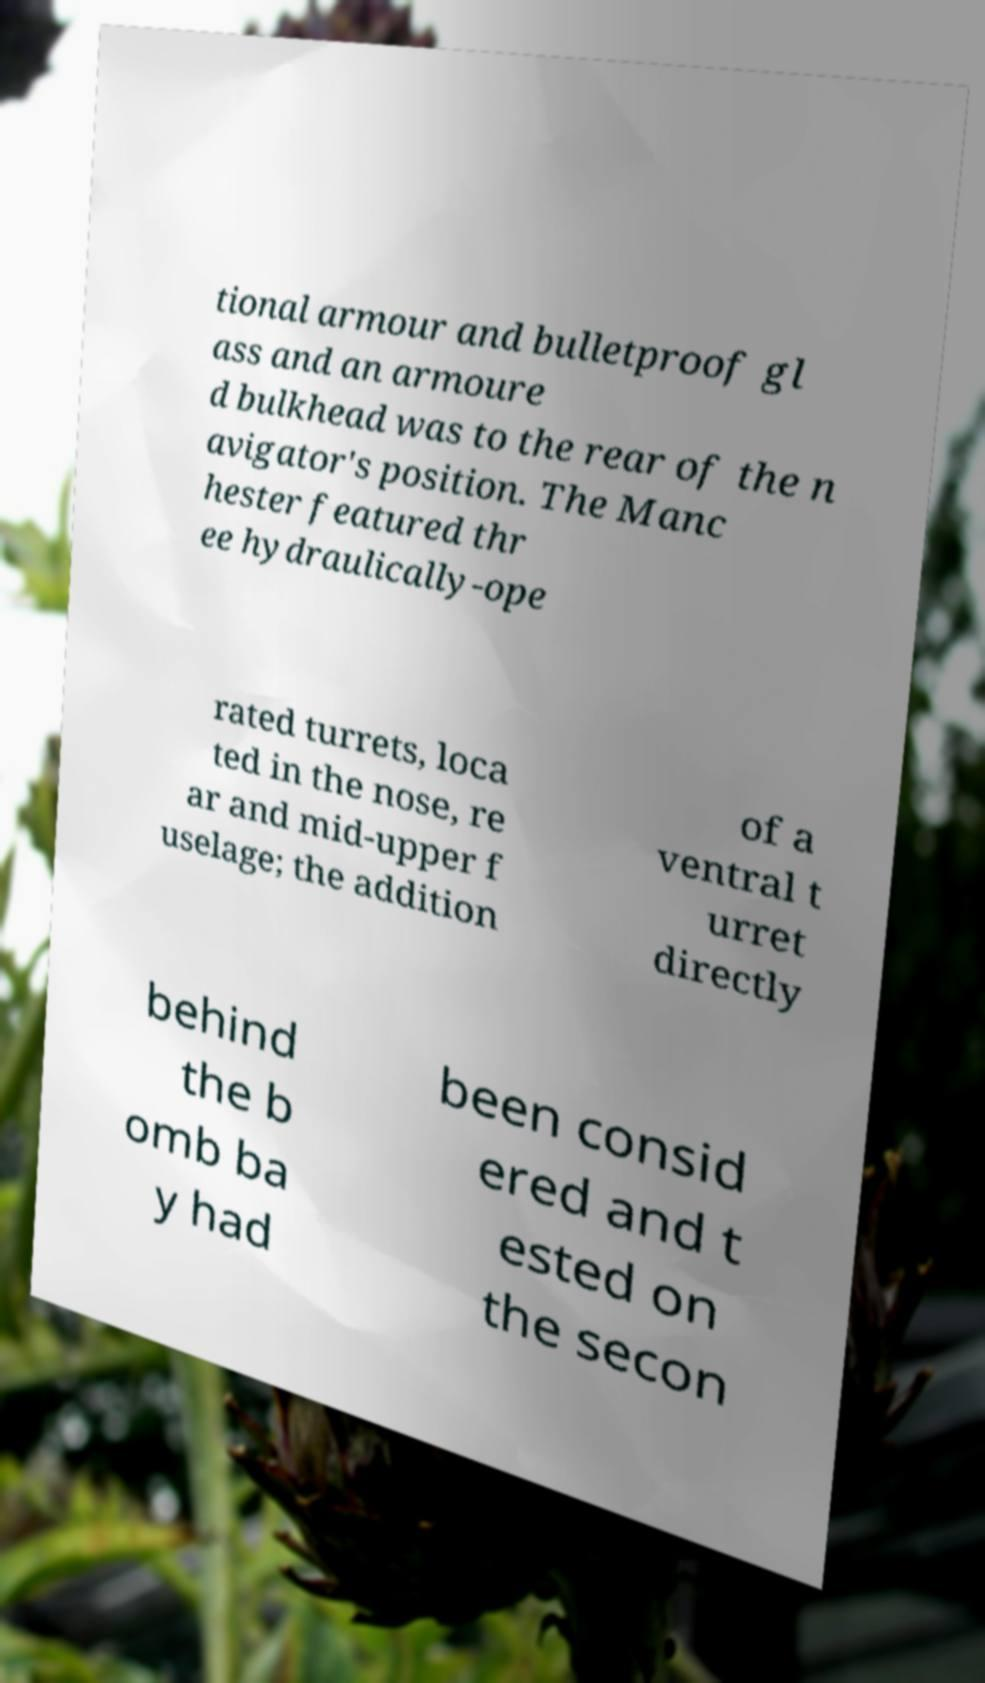For documentation purposes, I need the text within this image transcribed. Could you provide that? tional armour and bulletproof gl ass and an armoure d bulkhead was to the rear of the n avigator's position. The Manc hester featured thr ee hydraulically-ope rated turrets, loca ted in the nose, re ar and mid-upper f uselage; the addition of a ventral t urret directly behind the b omb ba y had been consid ered and t ested on the secon 